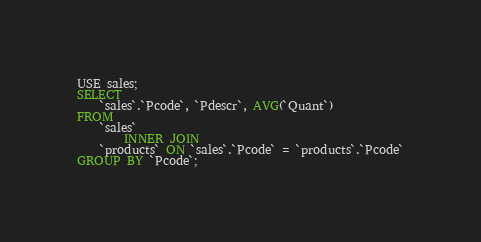Convert code to text. <code><loc_0><loc_0><loc_500><loc_500><_SQL_>USE sales;
SELECT 
    `sales`.`Pcode`, `Pdescr`, AVG(`Quant`)
FROM
    `sales`
        INNER JOIN
    `products` ON `sales`.`Pcode` = `products`.`Pcode`
GROUP BY `Pcode`;</code> 